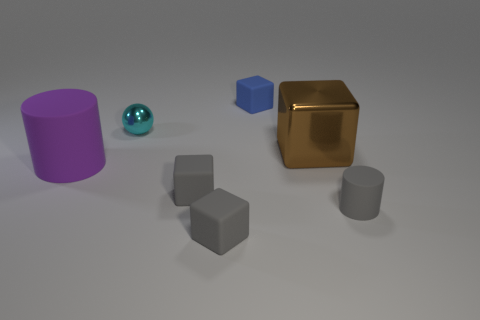Is there anything else that is made of the same material as the small cyan object?
Provide a succinct answer. Yes. How many metallic spheres have the same color as the large shiny block?
Ensure brevity in your answer.  0. What size is the matte cube that is behind the large thing in front of the big brown block?
Your response must be concise. Small. What is the shape of the blue thing?
Offer a very short reply. Cube. What is the big object that is in front of the big brown metal object made of?
Offer a very short reply. Rubber. What is the color of the cylinder to the left of the gray block behind the cylinder that is in front of the purple thing?
Give a very brief answer. Purple. What color is the cylinder that is the same size as the cyan ball?
Offer a very short reply. Gray. What number of rubber objects are either tiny cyan spheres or cylinders?
Your answer should be very brief. 2. What color is the big thing that is made of the same material as the tiny sphere?
Provide a short and direct response. Brown. What is the cube that is right of the tiny matte block behind the big brown metal block made of?
Offer a very short reply. Metal. 